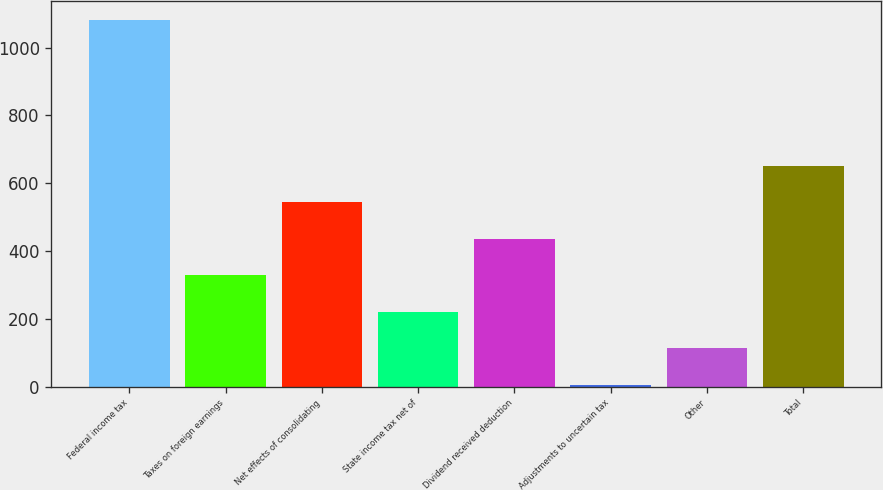Convert chart to OTSL. <chart><loc_0><loc_0><loc_500><loc_500><bar_chart><fcel>Federal income tax<fcel>Taxes on foreign earnings<fcel>Net effects of consolidating<fcel>State income tax net of<fcel>Dividend received deduction<fcel>Adjustments to uncertain tax<fcel>Other<fcel>Total<nl><fcel>1082<fcel>328.1<fcel>543.5<fcel>220.4<fcel>435.8<fcel>5<fcel>112.7<fcel>651.2<nl></chart> 